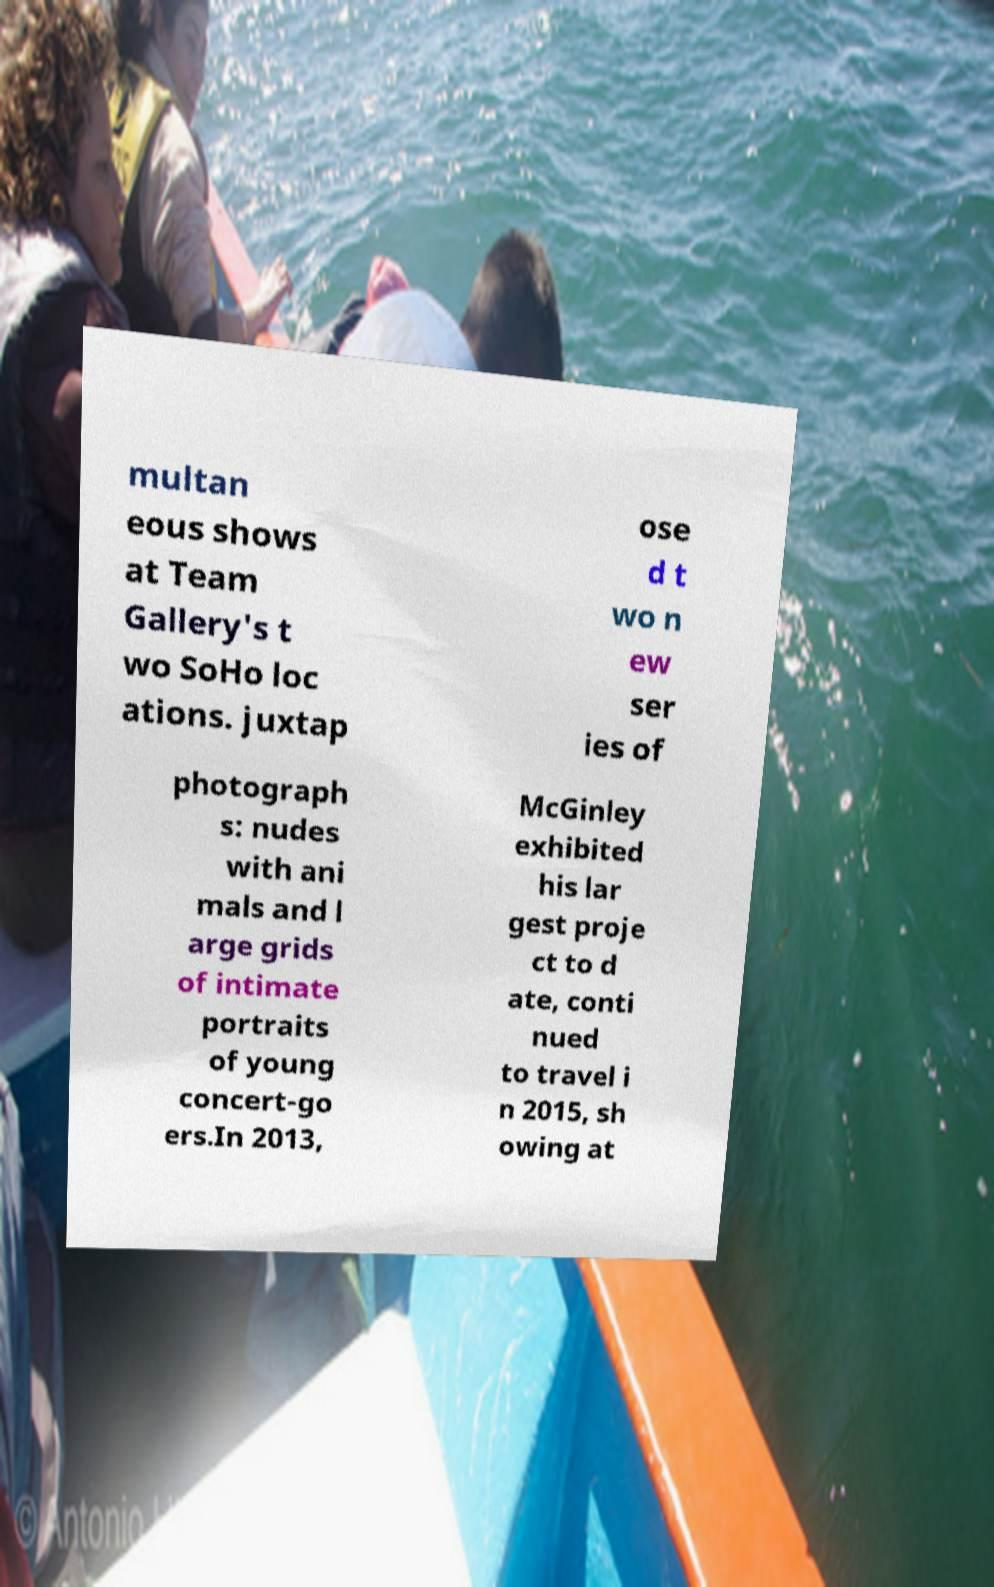I need the written content from this picture converted into text. Can you do that? multan eous shows at Team Gallery's t wo SoHo loc ations. juxtap ose d t wo n ew ser ies of photograph s: nudes with ani mals and l arge grids of intimate portraits of young concert-go ers.In 2013, McGinley exhibited his lar gest proje ct to d ate, conti nued to travel i n 2015, sh owing at 